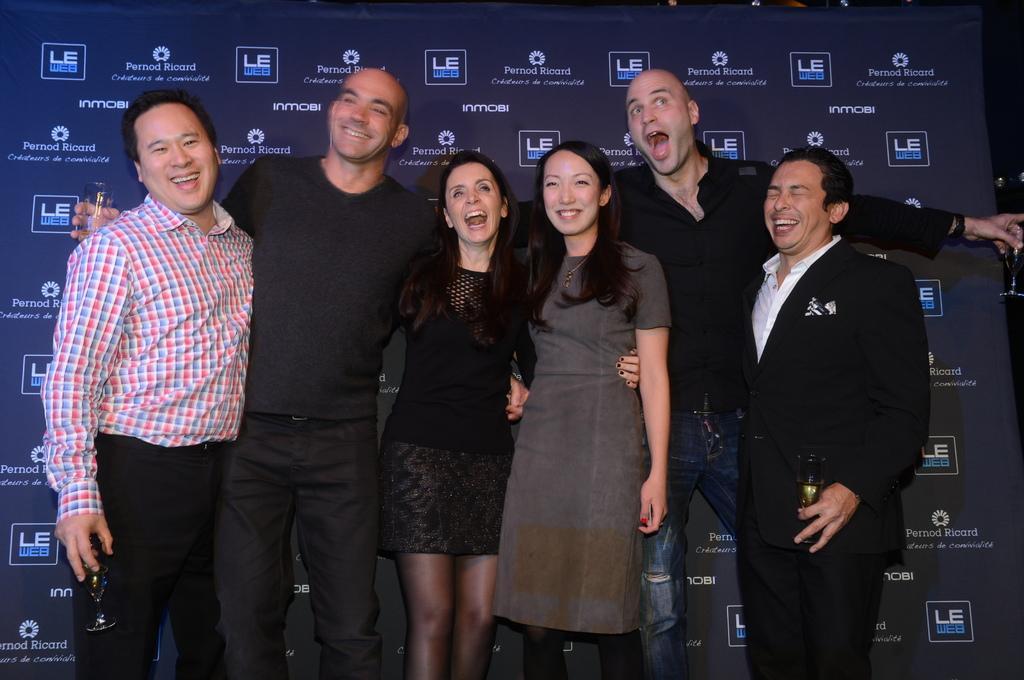Can you describe this image briefly? In this image we can see a group of people standing holding each other. In that some people are holding the glasses. On the backside we can see a board with some text on it. 